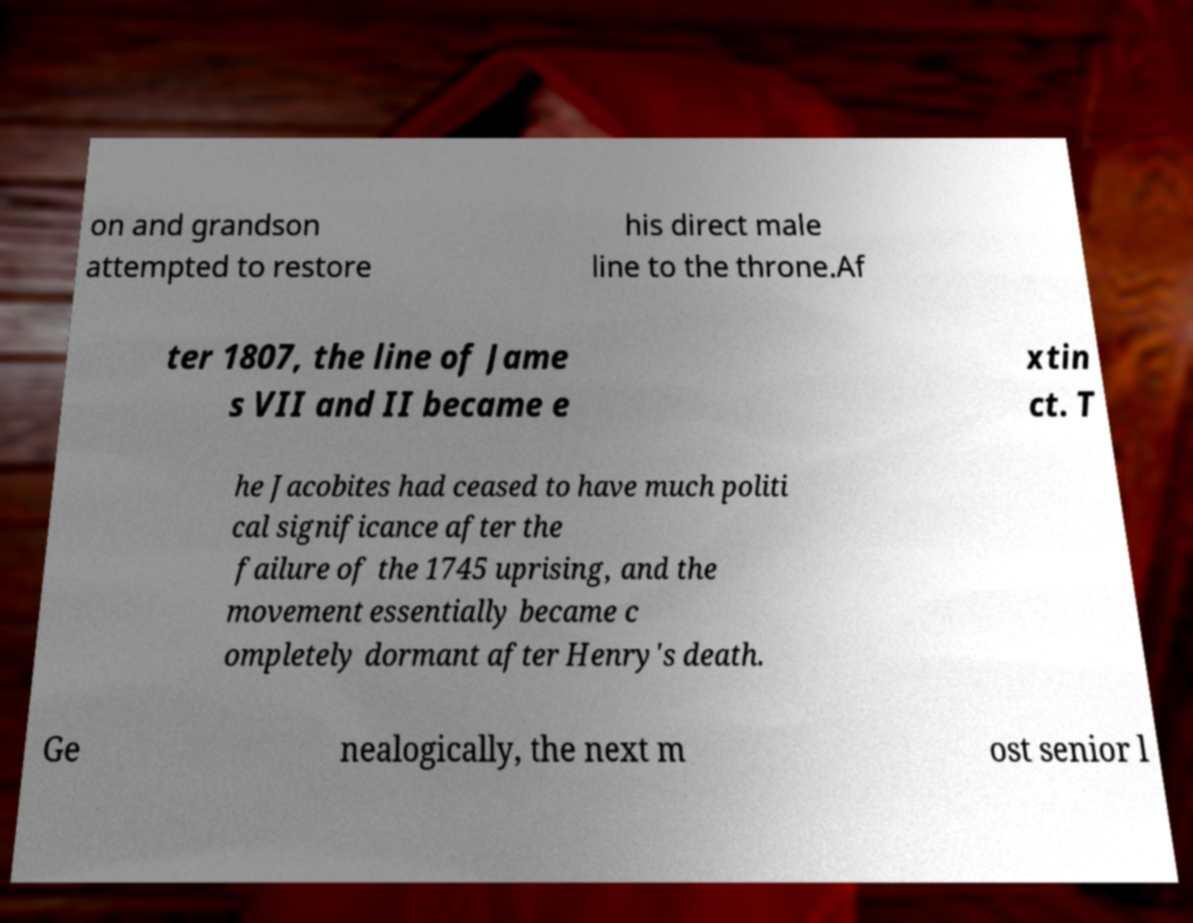What messages or text are displayed in this image? I need them in a readable, typed format. on and grandson attempted to restore his direct male line to the throne.Af ter 1807, the line of Jame s VII and II became e xtin ct. T he Jacobites had ceased to have much politi cal significance after the failure of the 1745 uprising, and the movement essentially became c ompletely dormant after Henry's death. Ge nealogically, the next m ost senior l 